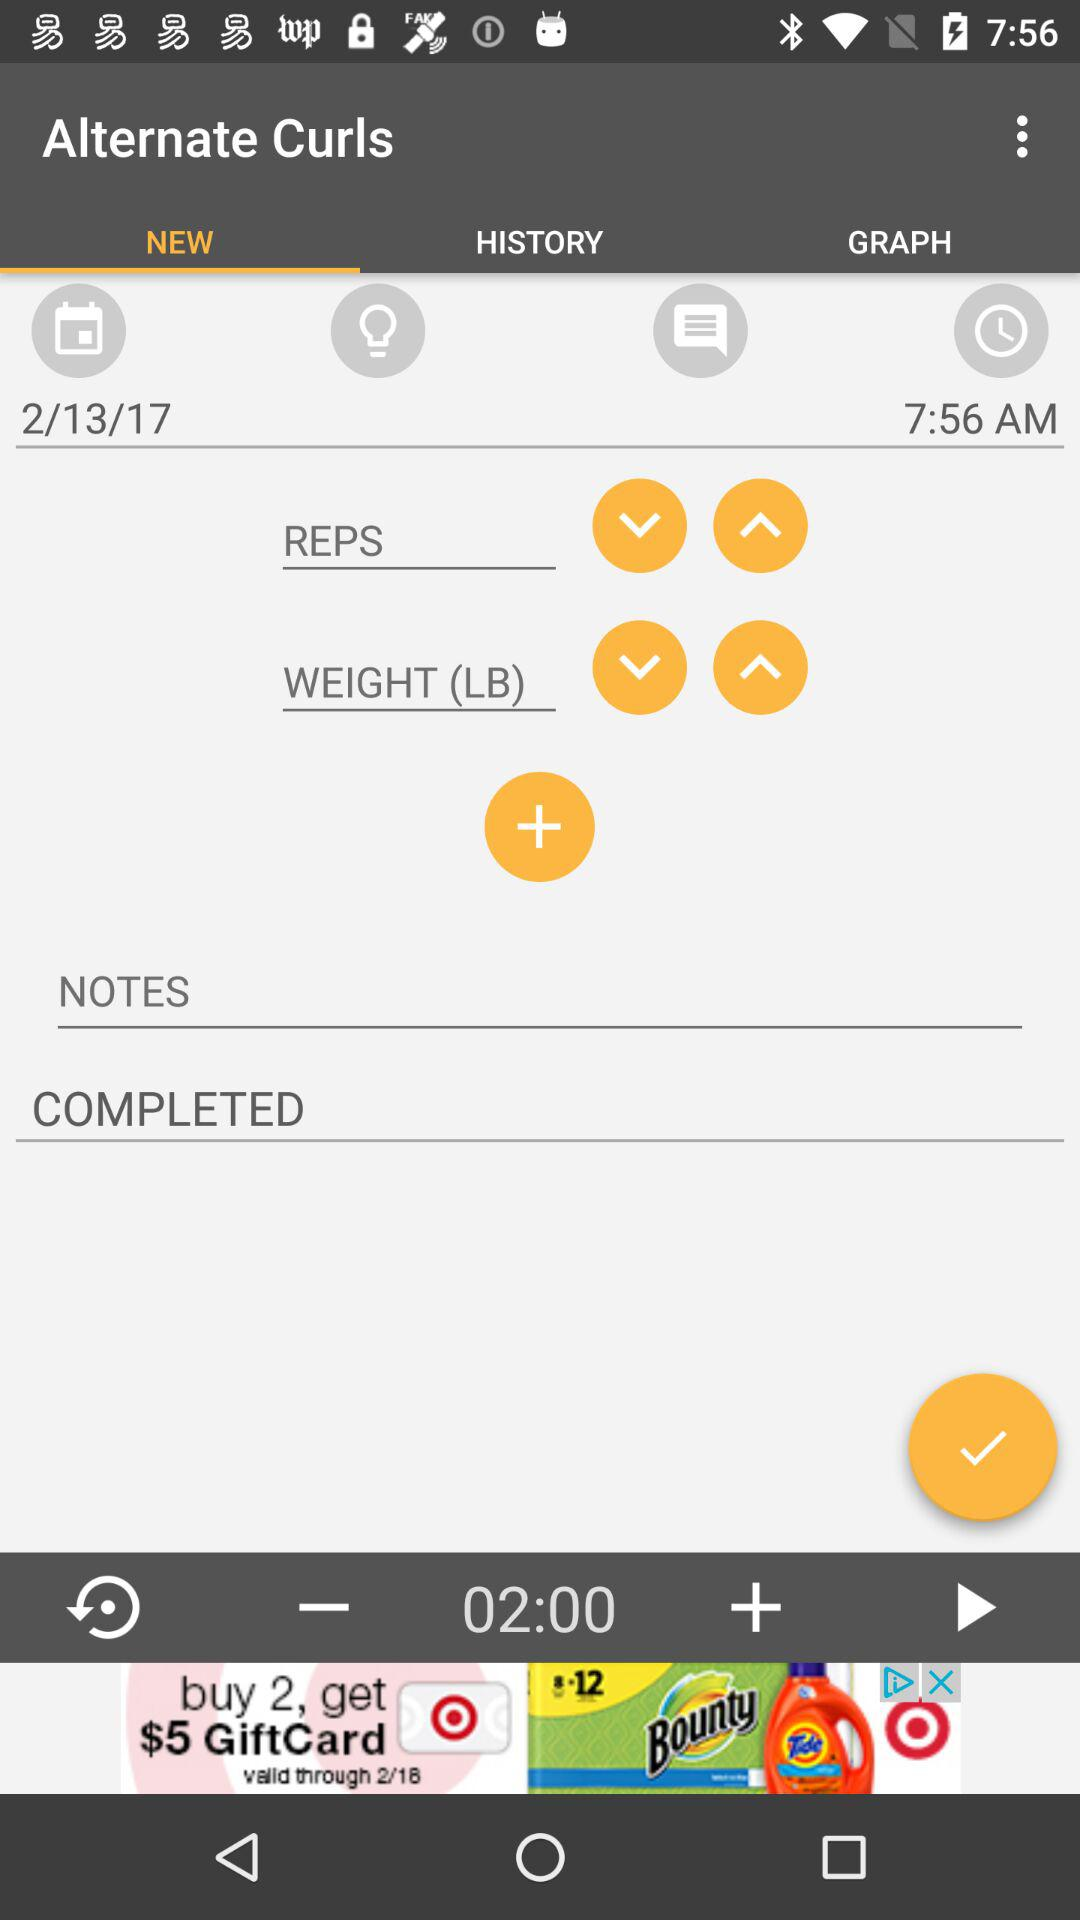What duration is given at the bottom of the screen? The given duration at the bottom of the screen is 2 minutes. 